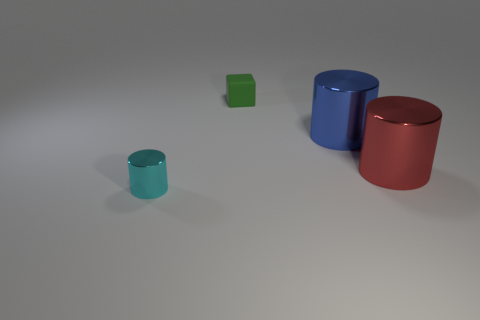How does the lighting in the image affect the appearance of the cylinders? The cylinders are cast with a soft, diffused light which highlights their colors gently. It creates subtle shadows on the ground, indicating a consistent light source and gives depth to the image. 